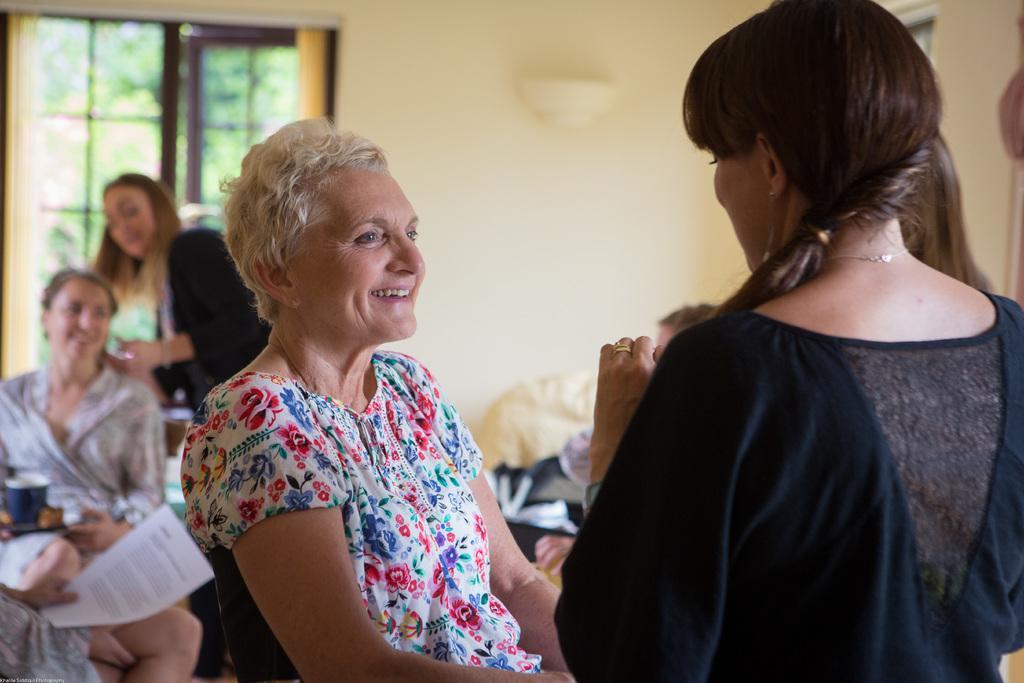Describe this image in one or two sentences. In the picture we can see two women are standing and talking to each other and one woman is smiling and behind them, we can see a woman sitting and one woman is standing and doing a hair style to her and behind them, we can see a window and curtains near it and beside it we can see a wall and near it we can see a person sitting. 